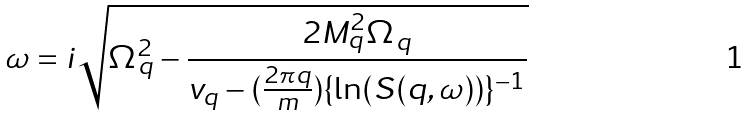<formula> <loc_0><loc_0><loc_500><loc_500>\omega = i \sqrt { \Omega ^ { 2 } _ { q } - \frac { 2 M ^ { 2 } _ { q } \Omega _ { q } } { v _ { q } - ( \frac { 2 \pi q } { m } ) \{ \ln ( S ( q , \omega ) ) \} ^ { - 1 } } }</formula> 